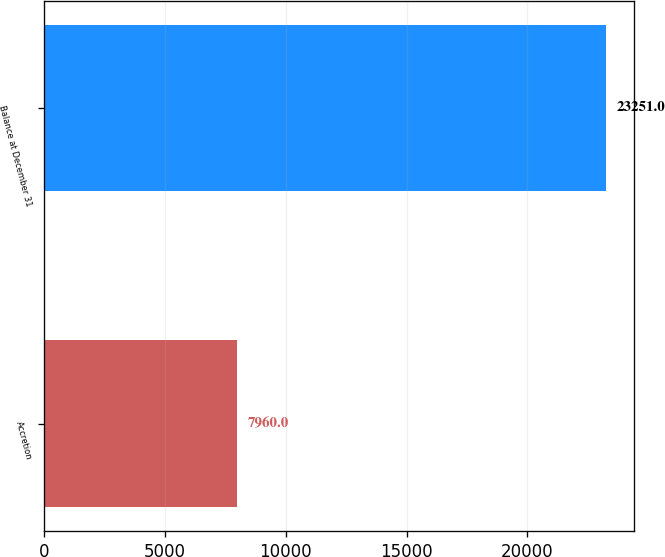Convert chart. <chart><loc_0><loc_0><loc_500><loc_500><bar_chart><fcel>Accretion<fcel>Balance at December 31<nl><fcel>7960<fcel>23251<nl></chart> 